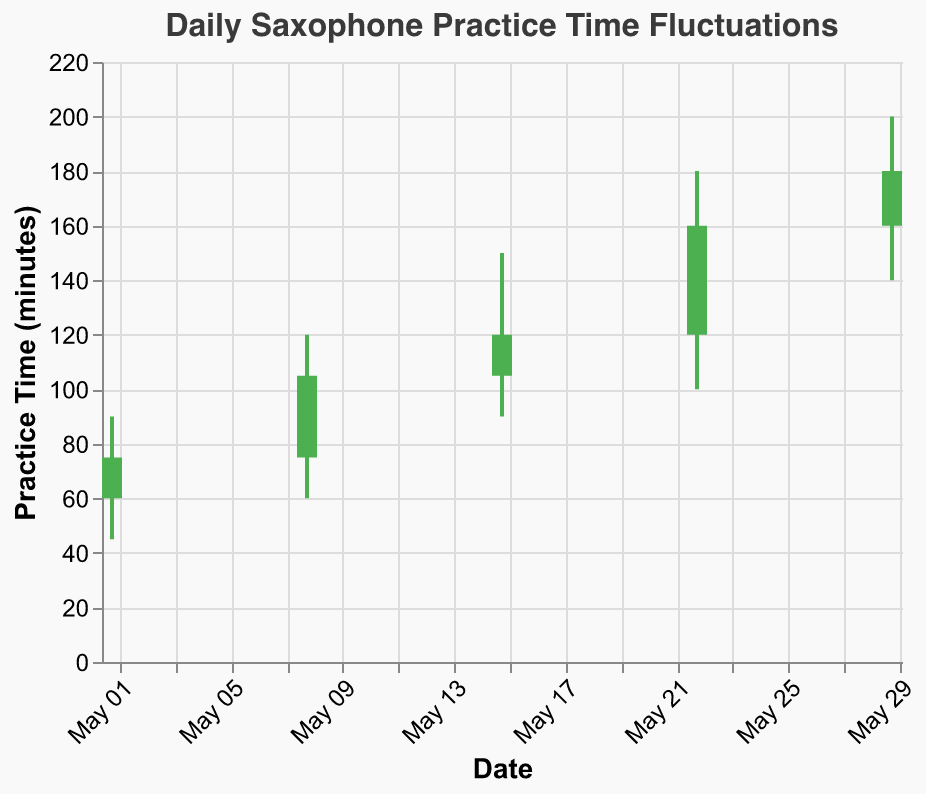What is the title of the figure? The title is usually placed at the top of a figure and provides a summary description. In this case, it reads: "Daily Saxophone Practice Time Fluctuations".
Answer: Daily Saxophone Practice Time Fluctuations How many data points are present in the figure? By looking at the x-axis labeled with dates, we can count the distinct data points corresponding to different dates. In this case, the dates are 2023-05-01, 2023-05-08, 2023-05-15, 2023-05-22, and 2023-05-29, making it 5 data points.
Answer: 5 What are the axes labels and their titles? The x-axis is labeled "Date," and the y-axis is labeled "Practice Time (minutes)". These labels help identify what the respective axes represent.
Answer: Date; Practice Time (minutes) On which date did the practice time have the highest recorded value? By looking at the highest values (High) for each date, we can identify that the highest recorded value is 200 minutes on 2023-05-29.
Answer: 2023-05-29 What was the practice time range on 2023-05-15? The range of practice time is determined by subtracting the Low value from the High value. On 2023-05-15, High is 150 minutes, and Low is 90 minutes. So, the range is 150 - 90 = 60 minutes.
Answer: 60 minutes Which date had the greatest increase in practice time, comparing the Open and Close values? The increase in practice time is found by subtracting Open from Close. Calculating for each date:
- 2023-05-01: 75 - 60 = 15
- 2023-05-08: 105 - 75 = 30
- 2023-05-15: 120 - 105 = 15
- 2023-05-22: 160 - 120 = 40
- 2023-05-29: 180 - 160 = 20
The greatest increase is on 2023-05-22 with 40 minutes.
Answer: 2023-05-22 On which dates did the practice time decline from the opening to the closing? Checking the Open and Close values, a decline occurs if Close is less than Open. There are no dates where the Close value is less than the Open value.
Answer: None What is the average of the High values recorded over the month? To find the average, sum the High values and divide by the number of data points: (90 + 120 + 150 + 180 + 200) / 5 = 740 / 5 = 148 minutes.
Answer: 148 minutes Which date showed the least fluctuation in practice time? Fluctuation can be assessed by the range, High minus Low. Calculating for each date:
- 2023-05-01: 90 - 45 = 45
- 2023-05-08: 120 - 60 = 60
- 2023-05-15: 150 - 90 = 60
- 2023-05-22: 180 - 100 = 80
- 2023-05-29: 200 - 140 = 60
The least fluctuation is on 2023-05-01 with 45 minutes.
Answer: 2023-05-01 